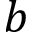Convert formula to latex. <formula><loc_0><loc_0><loc_500><loc_500>b</formula> 